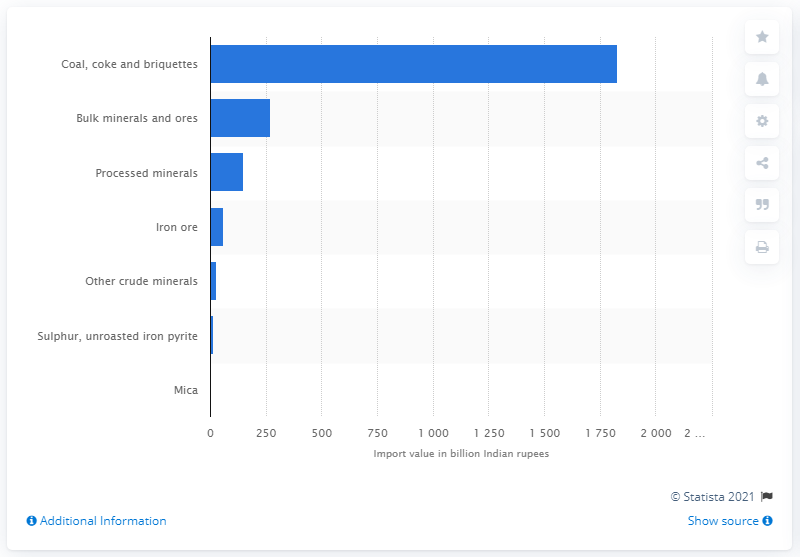Specify some key components in this picture. In the fiscal year 2019, the amount of Mica imported was 0.13. 